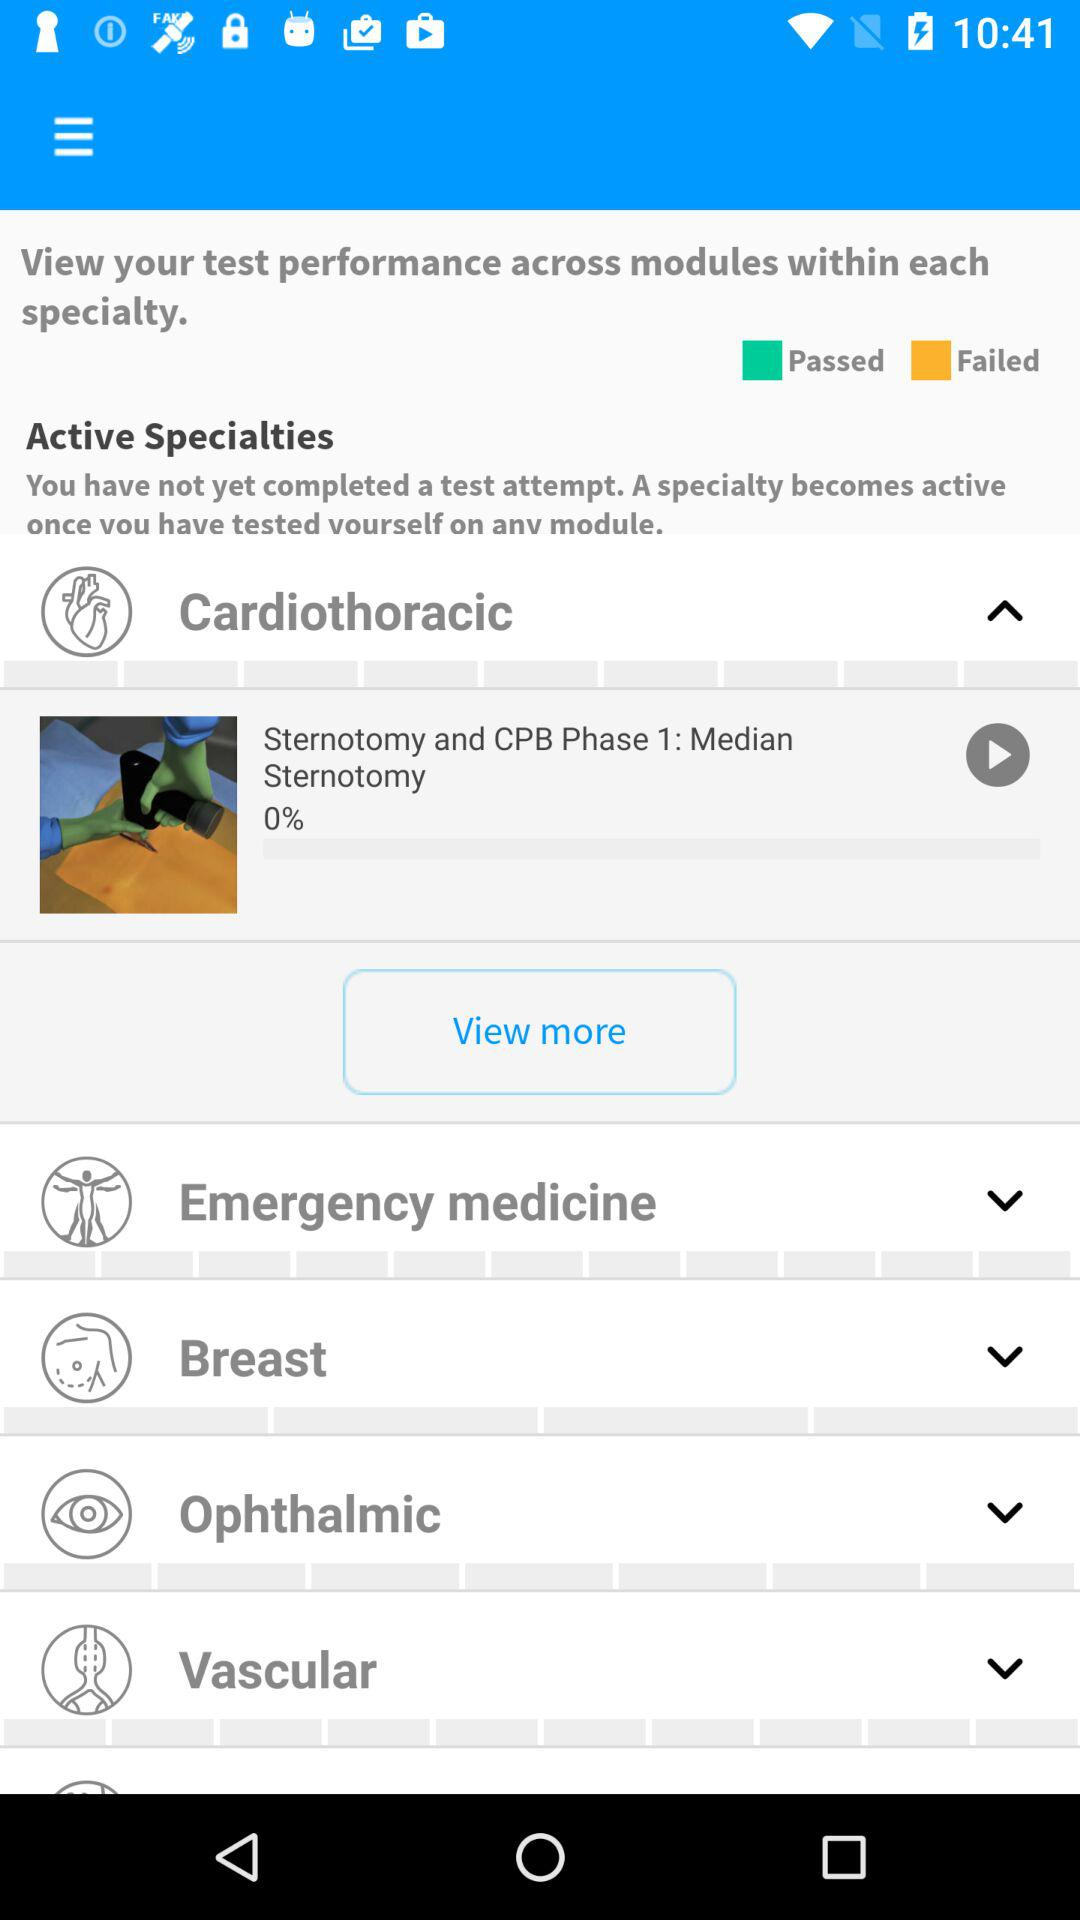What percentage of "Sternotomy and CPB Phase 1" has been downloaded? "Sternotomy and CPB Phase 1" has been downloaded 0%. 